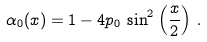Convert formula to latex. <formula><loc_0><loc_0><loc_500><loc_500>\alpha _ { 0 } ( x ) = 1 - 4 p _ { 0 } \, \sin ^ { 2 } \left ( \frac { x } { 2 } \right ) \, .</formula> 